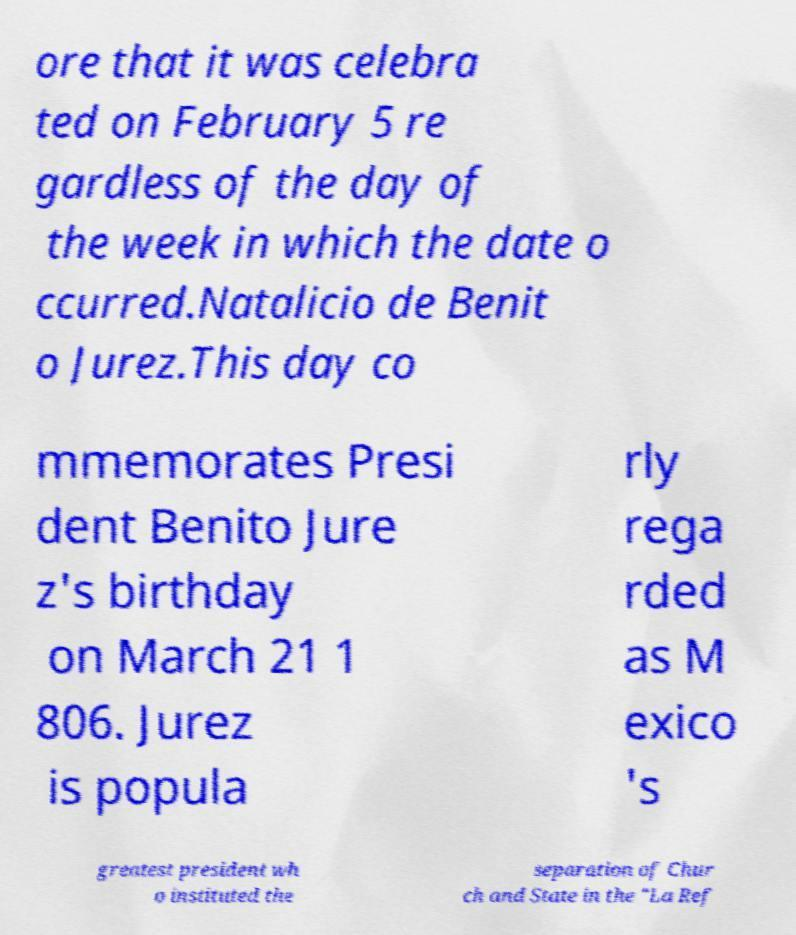For documentation purposes, I need the text within this image transcribed. Could you provide that? ore that it was celebra ted on February 5 re gardless of the day of the week in which the date o ccurred.Natalicio de Benit o Jurez.This day co mmemorates Presi dent Benito Jure z's birthday on March 21 1 806. Jurez is popula rly rega rded as M exico 's greatest president wh o instituted the separation of Chur ch and State in the "La Ref 